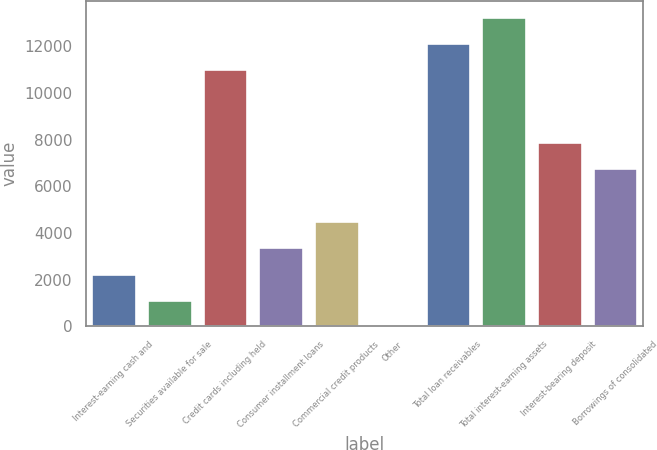Convert chart. <chart><loc_0><loc_0><loc_500><loc_500><bar_chart><fcel>Interest-earning cash and<fcel>Securities available for sale<fcel>Credit cards including held<fcel>Consumer installment loans<fcel>Commercial credit products<fcel>Other<fcel>Total loan receivables<fcel>Total interest-earning assets<fcel>Interest-bearing deposit<fcel>Borrowings of consolidated<nl><fcel>2263.4<fcel>1132.2<fcel>11015<fcel>3394.6<fcel>4525.8<fcel>1<fcel>12146.2<fcel>13277.4<fcel>7919.4<fcel>6788.2<nl></chart> 